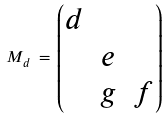Convert formula to latex. <formula><loc_0><loc_0><loc_500><loc_500>M _ { d } \, = \, \begin{pmatrix} d & & \\ & e & \\ & g & f \end{pmatrix}</formula> 